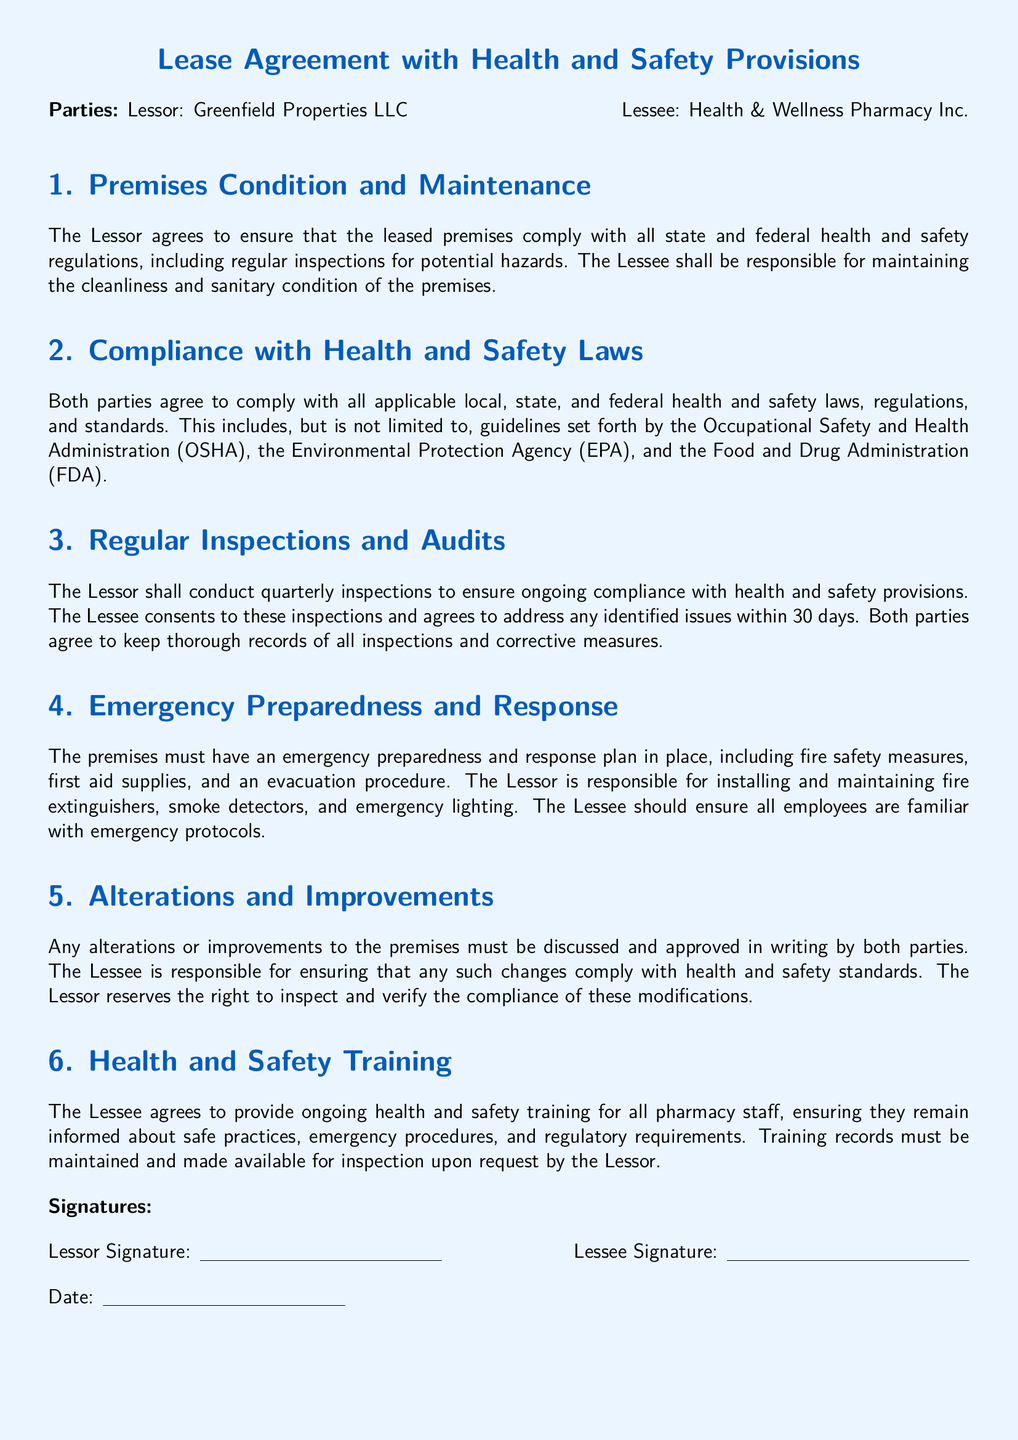What is the name of the Lessor? The Lessor is identified as Greenfield Properties LLC in the document.
Answer: Greenfield Properties LLC What is the Lessee's responsibility regarding premises cleanliness? The Lessee is responsible for maintaining the cleanliness and sanitary condition of the premises according to the document.
Answer: Cleanliness and sanitary condition How often will inspections be conducted by the Lessor? The document states that the Lessor will conduct quarterly inspections for compliance with health and safety provisions.
Answer: Quarterly Which organization's regulations must both parties comply with? The document mentions compliance with regulations from the Occupational Safety and Health Administration (OSHA).
Answer: Occupational Safety and Health Administration (OSHA) What must the premises have in terms of emergency preparedness? An emergency preparedness and response plan, including fire safety measures, is required per the document.
Answer: Emergency preparedness and response plan Who is responsible for installing fire extinguishers? The document specifies that the Lessor is responsible for installing and maintaining fire extinguishers.
Answer: Lessor What type of training must the Lessee provide to pharmacy staff? The Lessee is required to provide ongoing health and safety training for all pharmacy staff.
Answer: Ongoing health and safety training What must be done regarding alterations to the premises? Any alterations or improvements must be discussed and approved in writing by both parties according to the document.
Answer: Discussed and approved in writing How long does the Lessee have to address issues identified during inspections? The Lessee must address any identified issues within 30 days as stated in the document.
Answer: 30 days 